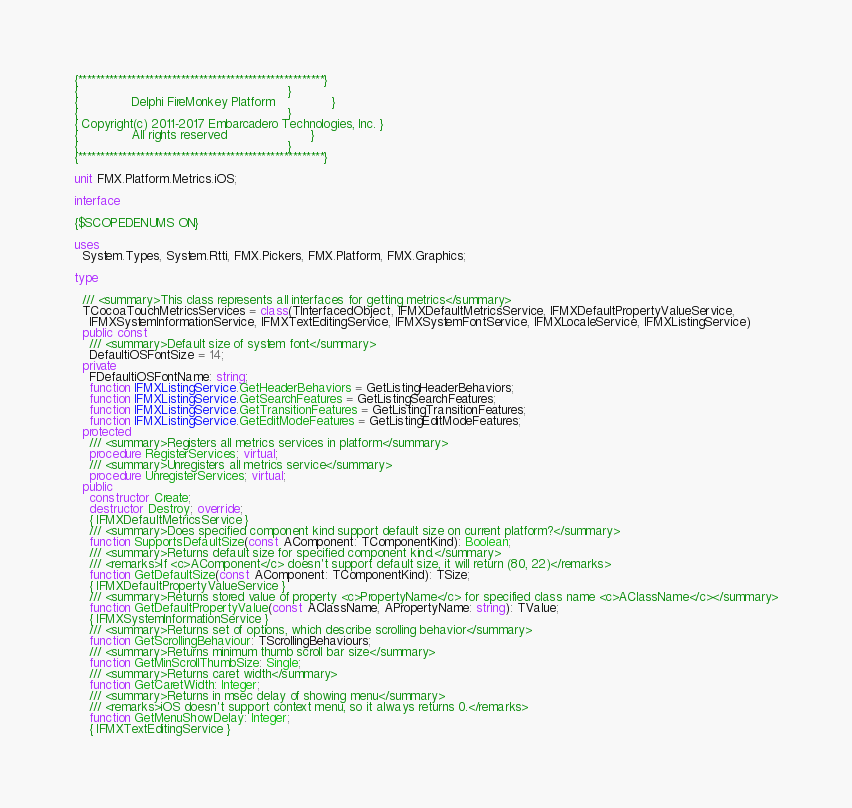Convert code to text. <code><loc_0><loc_0><loc_500><loc_500><_Pascal_>{*******************************************************}
{                                                       }
{              Delphi FireMonkey Platform               }
{                                                       }
{ Copyright(c) 2011-2017 Embarcadero Technologies, Inc. }
{              All rights reserved                      }
{                                                       }
{*******************************************************}

unit FMX.Platform.Metrics.iOS;

interface

{$SCOPEDENUMS ON}

uses
  System.Types, System.Rtti, FMX.Pickers, FMX.Platform, FMX.Graphics;

type

  /// <summary>This class represents all interfaces for getting metrics</summary>
  TCocoaTouchMetricsServices = class(TInterfacedObject, IFMXDefaultMetricsService, IFMXDefaultPropertyValueService,
    IFMXSystemInformationService, IFMXTextEditingService, IFMXSystemFontService, IFMXLocaleService, IFMXListingService)
  public const
    /// <summary>Default size of system font</summary>
    DefaultiOSFontSize = 14;
  private
    FDefaultiOSFontName: string;
    function IFMXListingService.GetHeaderBehaviors = GetListingHeaderBehaviors;
    function IFMXListingService.GetSearchFeatures = GetListingSearchFeatures;
    function IFMXListingService.GetTransitionFeatures = GetListingTransitionFeatures;
    function IFMXListingService.GetEditModeFeatures = GetListingEditModeFeatures;
  protected
    /// <summary>Registers all metrics services in platform</summary>
    procedure RegisterServices; virtual;
    /// <summary>Unregisters all metrics service</summary>
    procedure UnregisterServices; virtual;
  public
    constructor Create;
    destructor Destroy; override;
    { IFMXDefaultMetricsService }
    /// <summary>Does specified component kind support default size on current platform?</summary>
    function SupportsDefaultSize(const AComponent: TComponentKind): Boolean;
    /// <summary>Returns default size for specified component kind.</summary>
    /// <remarks>If <c>AComponent</c> doesn't support default size, it will return (80, 22)</remarks>
    function GetDefaultSize(const AComponent: TComponentKind): TSize;
    { IFMXDefaultPropertyValueService }
    /// <summary>Returns stored value of property <c>PropertyName</c> for specified class name <c>AClassName</c></summary>
    function GetDefaultPropertyValue(const AClassName, APropertyName: string): TValue;
    { IFMXSystemInformationService }
    /// <summary>Returns set of options, which describe scrolling behavior</summary>
    function GetScrollingBehaviour: TScrollingBehaviours;
    /// <summary>Returns minimum thumb scroll bar size</summary>
    function GetMinScrollThumbSize: Single;
    /// <summary>Returns caret width</summary>
    function GetCaretWidth: Integer;
    /// <summary>Returns in msec delay of showing menu</summary>
    /// <remarks>iOS doesn't support context menu, so it always returns 0.</remarks>
    function GetMenuShowDelay: Integer;
    { IFMXTextEditingService }</code> 